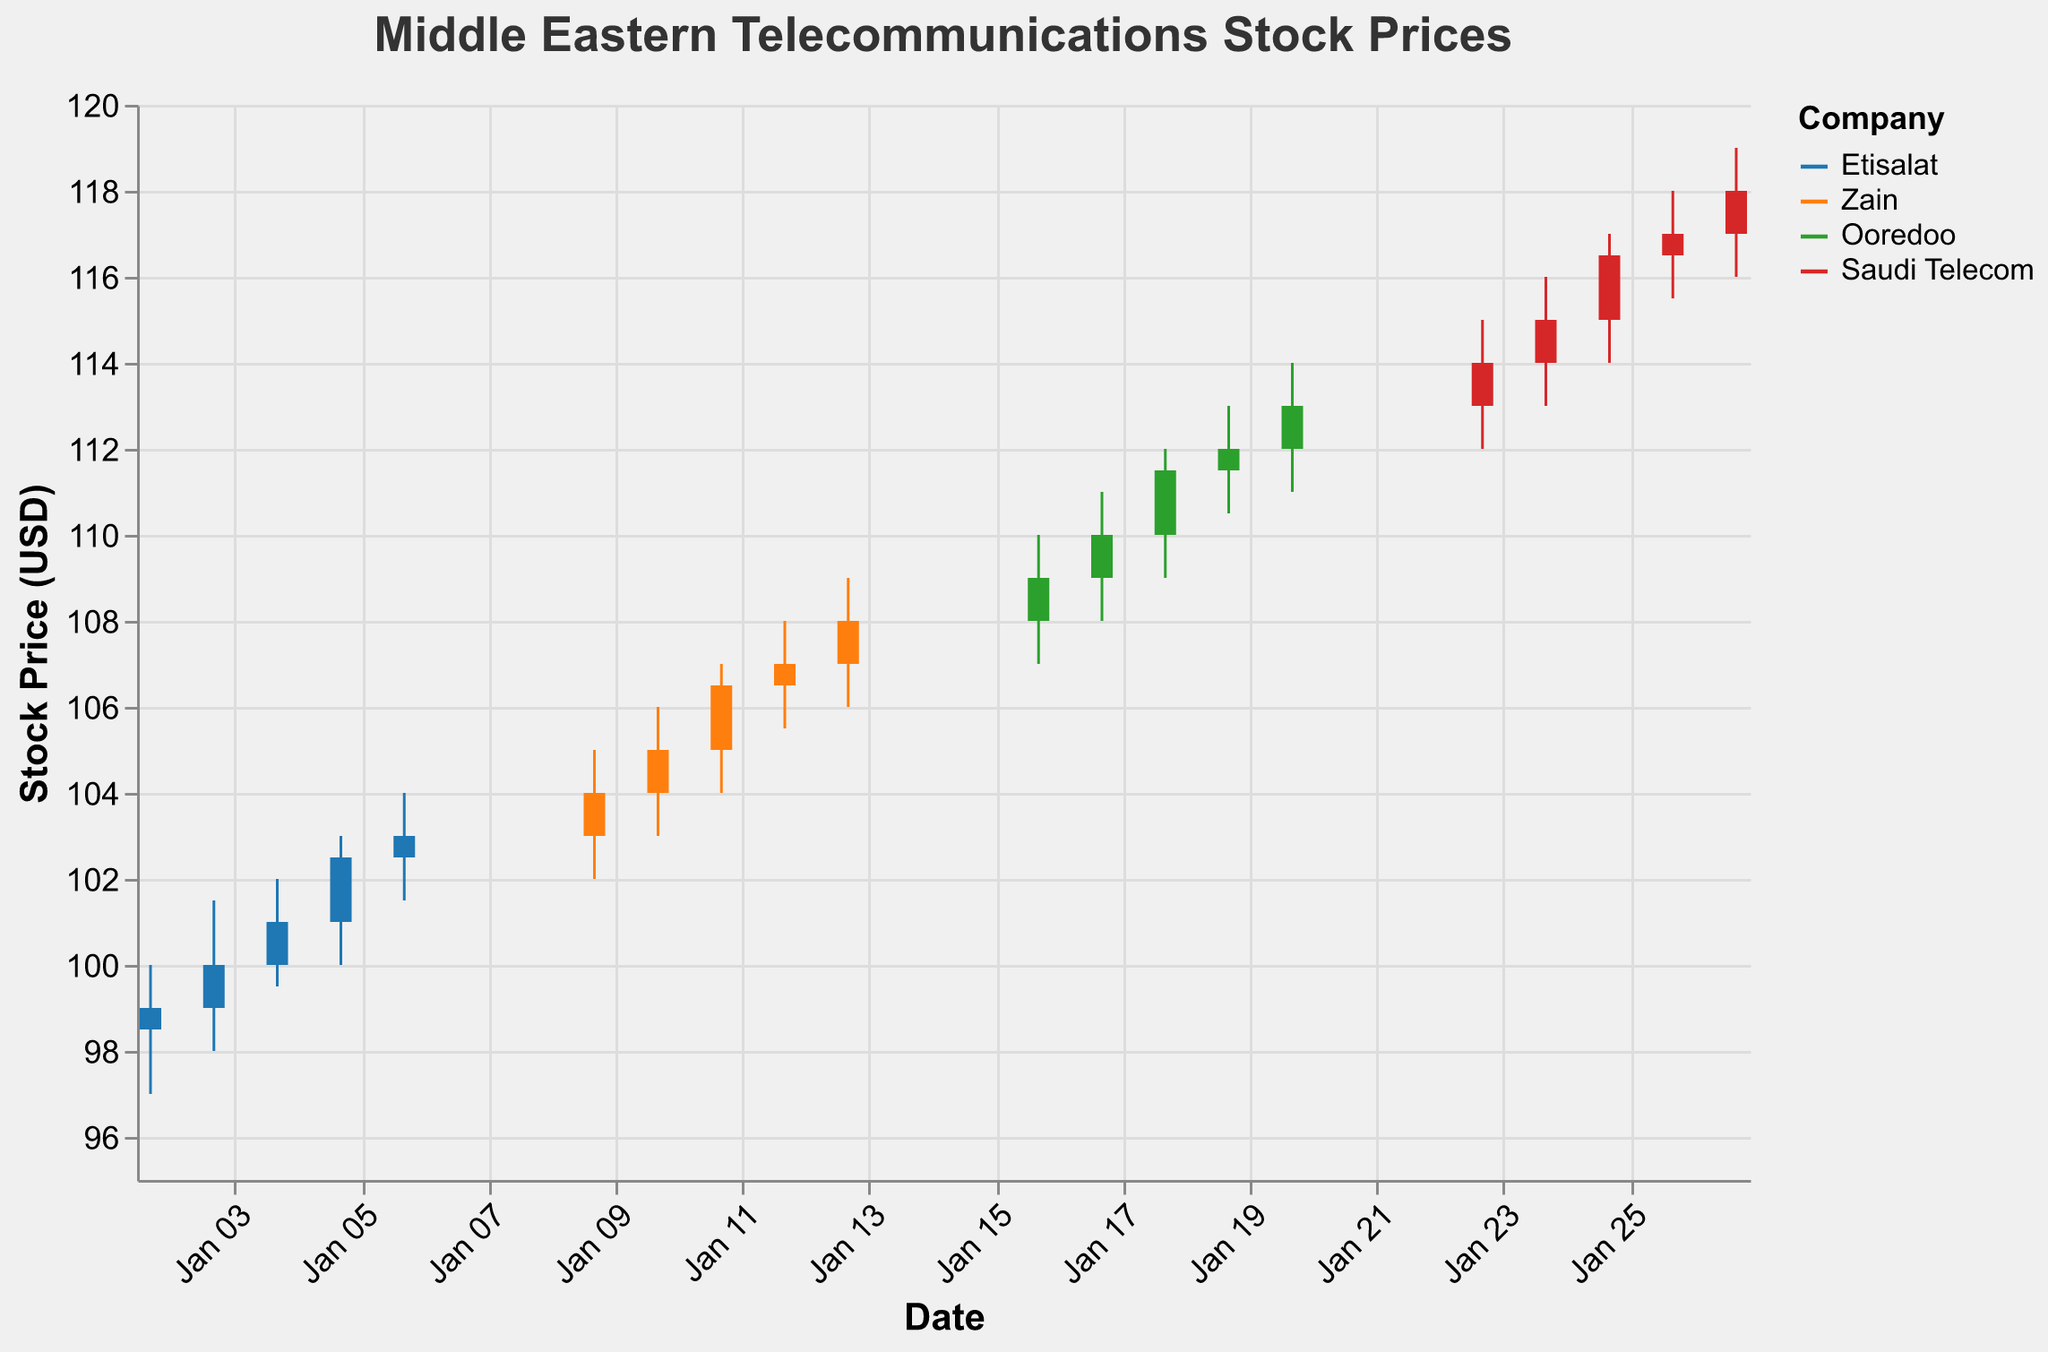What is the title of the plot? The title of the plot is typically written at the top and describes the content. Here, it reads "Middle Eastern Telecommunications Stock Prices."
Answer: Middle Eastern Telecommunications Stock Prices Which company had the highest stock price close on January 27th, 2023? On the x-axis, find the date January 27th, 2023, and look at the closing price value for each company. Saudi Telecom has the highest close on January 27th.
Answer: Saudi Telecom What is the average closing price of Etisalat from January 2nd to January 6th, 2023? Calculate the average by summing the closing prices of Etisalat from January 2nd to January 6th and dividing by the number of days: (99.0 + 100.0 + 101.0 + 102.5 + 103.0) / 5 = 101.1
Answer: 101.1 Which company showed a continuous increase in closing prices over their recorded five-day period? Compare the closing prices for each company over their respective five-day periods, and only Zain shows a continuous increase in closing prices from January 9th to January 13th.
Answer: Zain What is the midpoint of the high and low prices for Ooredoo on January 20th, 2023? Find the high (114.0) and low (111.0) prices for Ooredoo on January 20th, then calculate the midpoint: (114.0 + 111.0) / 2 = 112.5
Answer: 112.5 How does the closing price of Saudi Telecom trend from January 23rd to January 27th, 2023? Look at the closing prices of Saudi Telecom for these dates on the x-axis. They show an increasing trend: 114.0, 115.0, 116.5, 117.0, 118.0.
Answer: Increasing Which day had the highest closing price for Zain? Look through the dates under Zain and find January 13th has the highest closing price, 108.0. Compare each date's closing prices.
Answer: January 13th What is the total volume traded for Ooredoo from January 16th to January 20th, 2023? Sum the volumes from January 16th to January 20th for Ooredoo: 570000 + 590000 + 600000 + 620000 + 630000 = 3010000
Answer: 3010000 How does the closing price comparison between Etisalat and Zain on January 10th, 2023? Look at both companies’ closing prices on January 10th. Etisalat at 103.0 while Zain at 105.0.
Answer: Zain has a higher closing price 